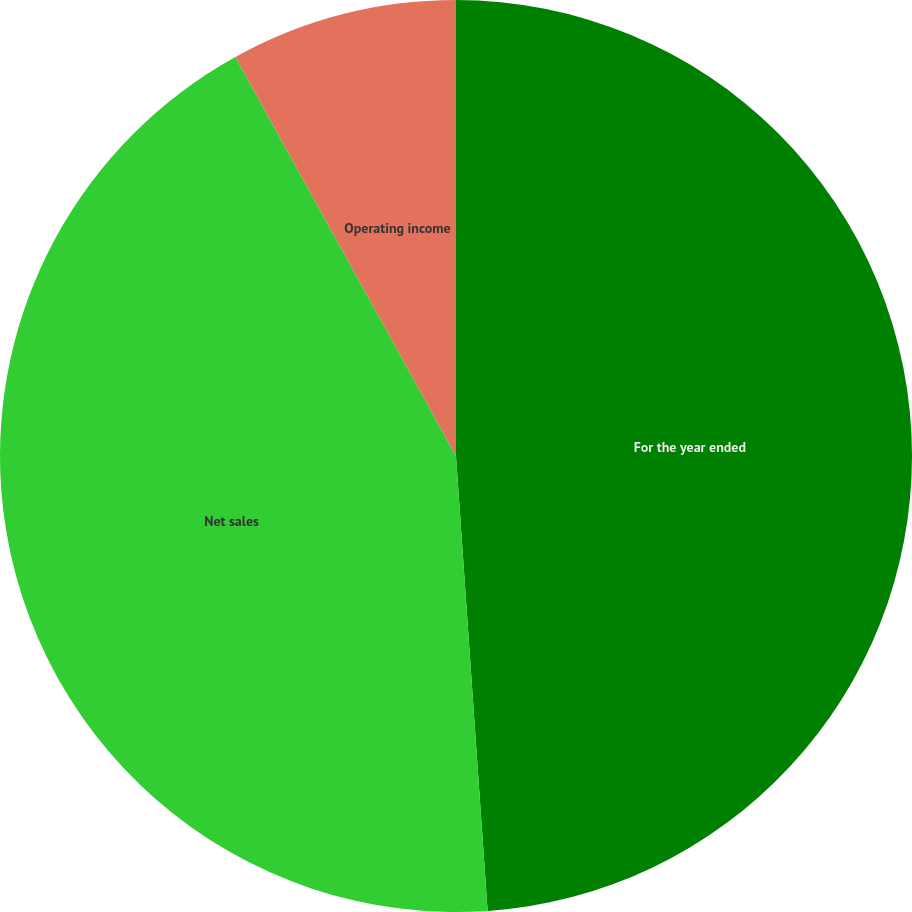Convert chart. <chart><loc_0><loc_0><loc_500><loc_500><pie_chart><fcel>For the year ended<fcel>Net sales<fcel>Operating income<nl><fcel>48.9%<fcel>43.07%<fcel>8.04%<nl></chart> 